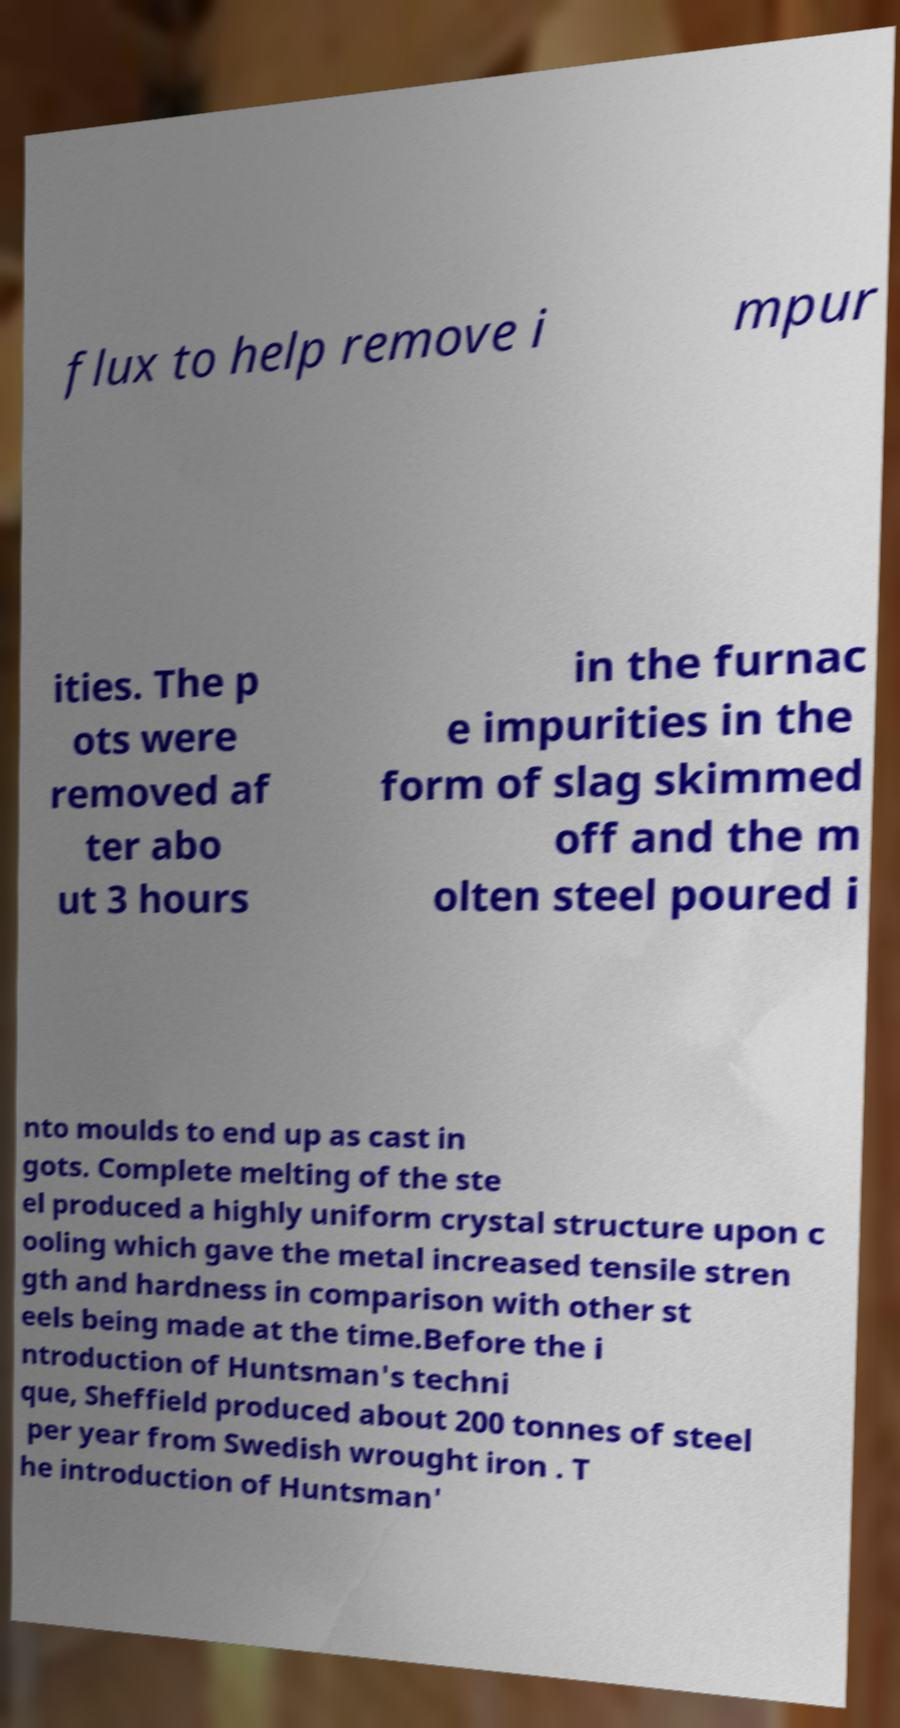For documentation purposes, I need the text within this image transcribed. Could you provide that? flux to help remove i mpur ities. The p ots were removed af ter abo ut 3 hours in the furnac e impurities in the form of slag skimmed off and the m olten steel poured i nto moulds to end up as cast in gots. Complete melting of the ste el produced a highly uniform crystal structure upon c ooling which gave the metal increased tensile stren gth and hardness in comparison with other st eels being made at the time.Before the i ntroduction of Huntsman's techni que, Sheffield produced about 200 tonnes of steel per year from Swedish wrought iron . T he introduction of Huntsman' 